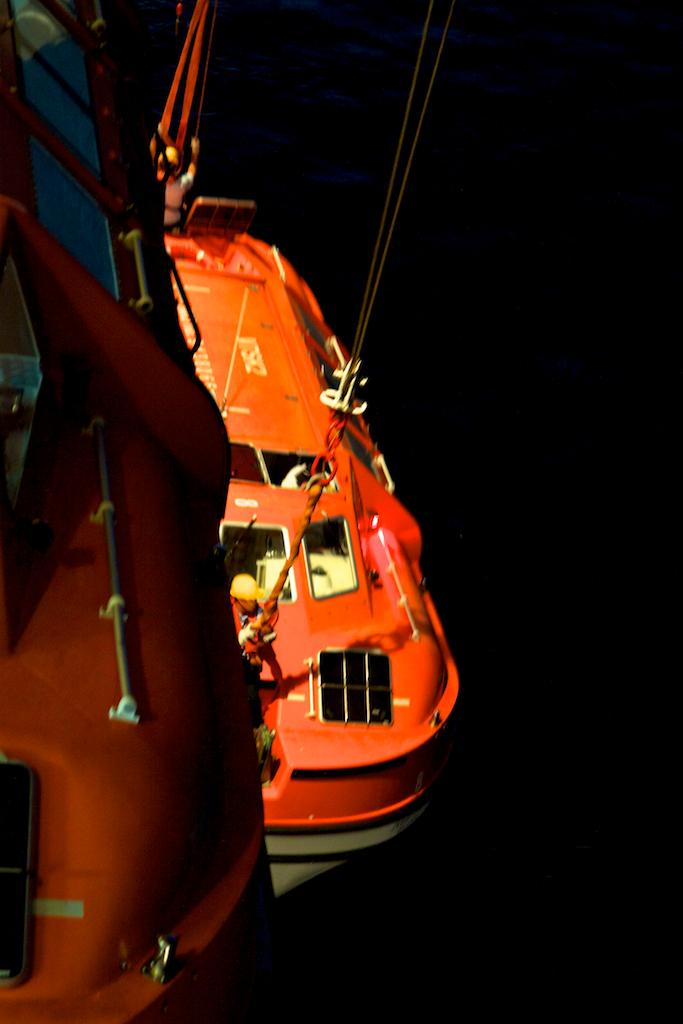What can be seen in the image related to water transportation? There are two boats in the image. What are the boats connected to or secured by in the image? There are ropes visible in the image, which may be used to connect or secure the boats. Are there any people present in the image? Yes, there are people present in the image. What is the color of the background in the image? The background of the image is dark. Where is the grape stored in the image? There is no grape present in the image. What type of division is taking place in the image? There is no division or separation of any kind depicted in the image. 